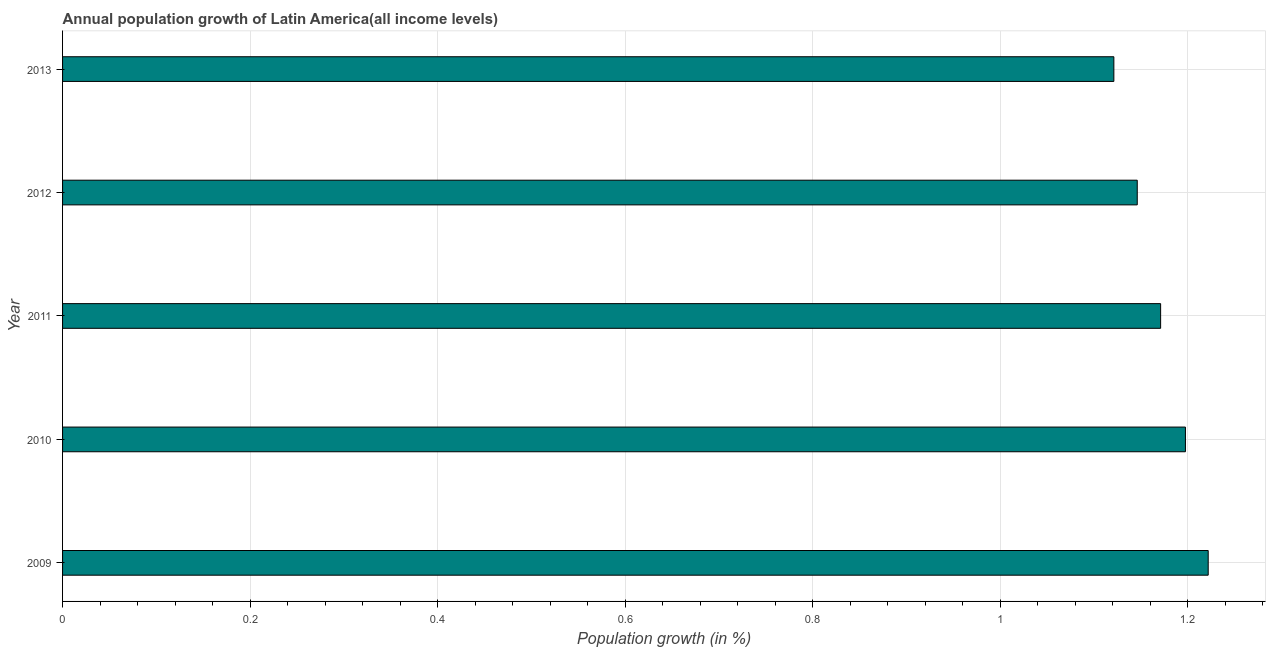Does the graph contain any zero values?
Your response must be concise. No. Does the graph contain grids?
Make the answer very short. Yes. What is the title of the graph?
Give a very brief answer. Annual population growth of Latin America(all income levels). What is the label or title of the X-axis?
Your answer should be compact. Population growth (in %). What is the population growth in 2011?
Provide a succinct answer. 1.17. Across all years, what is the maximum population growth?
Ensure brevity in your answer.  1.22. Across all years, what is the minimum population growth?
Your response must be concise. 1.12. In which year was the population growth maximum?
Your answer should be compact. 2009. In which year was the population growth minimum?
Offer a very short reply. 2013. What is the sum of the population growth?
Your response must be concise. 5.86. What is the difference between the population growth in 2011 and 2012?
Offer a terse response. 0.03. What is the average population growth per year?
Give a very brief answer. 1.17. What is the median population growth?
Provide a succinct answer. 1.17. In how many years, is the population growth greater than 0.8 %?
Keep it short and to the point. 5. What is the ratio of the population growth in 2012 to that in 2013?
Your answer should be compact. 1.02. Is the population growth in 2010 less than that in 2013?
Keep it short and to the point. No. Is the difference between the population growth in 2012 and 2013 greater than the difference between any two years?
Offer a very short reply. No. What is the difference between the highest and the second highest population growth?
Ensure brevity in your answer.  0.02. Is the sum of the population growth in 2009 and 2011 greater than the maximum population growth across all years?
Your response must be concise. Yes. In how many years, is the population growth greater than the average population growth taken over all years?
Your answer should be compact. 2. Are all the bars in the graph horizontal?
Offer a very short reply. Yes. What is the Population growth (in %) of 2009?
Your answer should be very brief. 1.22. What is the Population growth (in %) of 2010?
Provide a short and direct response. 1.2. What is the Population growth (in %) in 2011?
Provide a succinct answer. 1.17. What is the Population growth (in %) of 2012?
Offer a terse response. 1.15. What is the Population growth (in %) of 2013?
Provide a succinct answer. 1.12. What is the difference between the Population growth (in %) in 2009 and 2010?
Your response must be concise. 0.02. What is the difference between the Population growth (in %) in 2009 and 2011?
Offer a terse response. 0.05. What is the difference between the Population growth (in %) in 2009 and 2012?
Make the answer very short. 0.08. What is the difference between the Population growth (in %) in 2009 and 2013?
Ensure brevity in your answer.  0.1. What is the difference between the Population growth (in %) in 2010 and 2011?
Offer a very short reply. 0.03. What is the difference between the Population growth (in %) in 2010 and 2012?
Give a very brief answer. 0.05. What is the difference between the Population growth (in %) in 2010 and 2013?
Your response must be concise. 0.08. What is the difference between the Population growth (in %) in 2011 and 2012?
Give a very brief answer. 0.02. What is the difference between the Population growth (in %) in 2011 and 2013?
Your answer should be very brief. 0.05. What is the difference between the Population growth (in %) in 2012 and 2013?
Provide a succinct answer. 0.02. What is the ratio of the Population growth (in %) in 2009 to that in 2010?
Provide a short and direct response. 1.02. What is the ratio of the Population growth (in %) in 2009 to that in 2011?
Ensure brevity in your answer.  1.04. What is the ratio of the Population growth (in %) in 2009 to that in 2012?
Ensure brevity in your answer.  1.07. What is the ratio of the Population growth (in %) in 2009 to that in 2013?
Ensure brevity in your answer.  1.09. What is the ratio of the Population growth (in %) in 2010 to that in 2011?
Provide a succinct answer. 1.02. What is the ratio of the Population growth (in %) in 2010 to that in 2012?
Your answer should be very brief. 1.04. What is the ratio of the Population growth (in %) in 2010 to that in 2013?
Your response must be concise. 1.07. What is the ratio of the Population growth (in %) in 2011 to that in 2013?
Give a very brief answer. 1.04. 